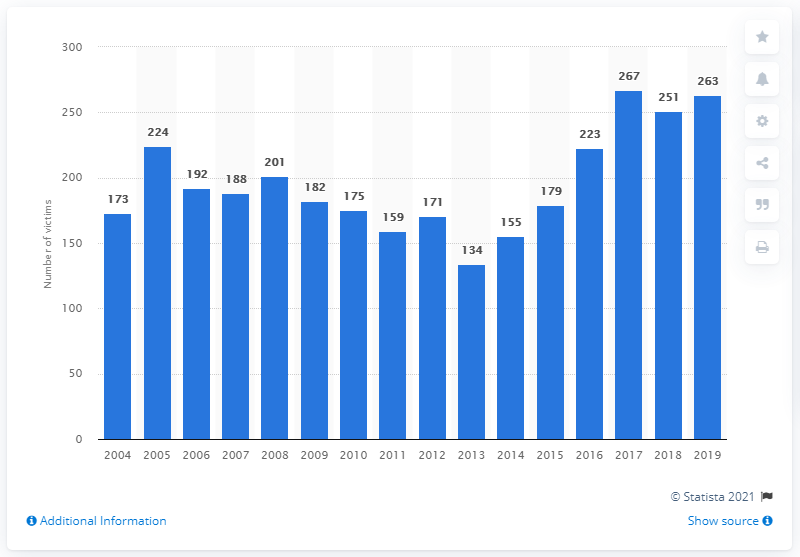Outline some significant characteristics in this image. In 2019, a total of 263 individuals in Canada lost their lives as a result of shooting incidents. 